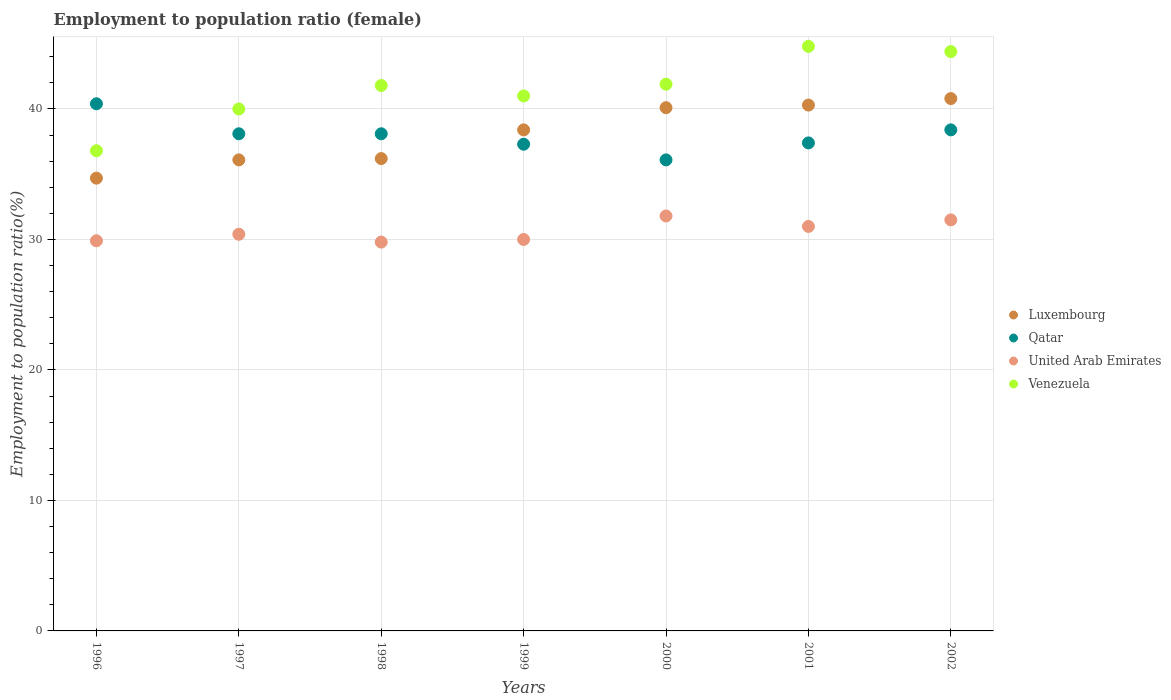Is the number of dotlines equal to the number of legend labels?
Offer a very short reply. Yes. What is the employment to population ratio in Luxembourg in 1999?
Your answer should be compact. 38.4. Across all years, what is the maximum employment to population ratio in Luxembourg?
Your answer should be very brief. 40.8. Across all years, what is the minimum employment to population ratio in United Arab Emirates?
Ensure brevity in your answer.  29.8. In which year was the employment to population ratio in United Arab Emirates maximum?
Offer a terse response. 2000. What is the total employment to population ratio in Venezuela in the graph?
Keep it short and to the point. 290.7. What is the difference between the employment to population ratio in Qatar in 1999 and that in 2002?
Ensure brevity in your answer.  -1.1. What is the difference between the employment to population ratio in Venezuela in 2002 and the employment to population ratio in United Arab Emirates in 1996?
Give a very brief answer. 14.5. What is the average employment to population ratio in United Arab Emirates per year?
Make the answer very short. 30.63. In the year 2001, what is the difference between the employment to population ratio in Luxembourg and employment to population ratio in Qatar?
Keep it short and to the point. 2.9. What is the ratio of the employment to population ratio in Luxembourg in 1997 to that in 1998?
Your response must be concise. 1. Is the employment to population ratio in United Arab Emirates in 1999 less than that in 2001?
Give a very brief answer. Yes. What is the difference between the highest and the second highest employment to population ratio in United Arab Emirates?
Ensure brevity in your answer.  0.3. In how many years, is the employment to population ratio in United Arab Emirates greater than the average employment to population ratio in United Arab Emirates taken over all years?
Your response must be concise. 3. Is the sum of the employment to population ratio in Luxembourg in 1999 and 2001 greater than the maximum employment to population ratio in Venezuela across all years?
Give a very brief answer. Yes. Is it the case that in every year, the sum of the employment to population ratio in Qatar and employment to population ratio in Luxembourg  is greater than the employment to population ratio in Venezuela?
Your answer should be very brief. Yes. How many dotlines are there?
Keep it short and to the point. 4. Are the values on the major ticks of Y-axis written in scientific E-notation?
Ensure brevity in your answer.  No. Does the graph contain any zero values?
Give a very brief answer. No. How many legend labels are there?
Keep it short and to the point. 4. What is the title of the graph?
Ensure brevity in your answer.  Employment to population ratio (female). What is the Employment to population ratio(%) in Luxembourg in 1996?
Offer a very short reply. 34.7. What is the Employment to population ratio(%) in Qatar in 1996?
Your response must be concise. 40.4. What is the Employment to population ratio(%) of United Arab Emirates in 1996?
Offer a very short reply. 29.9. What is the Employment to population ratio(%) in Venezuela in 1996?
Ensure brevity in your answer.  36.8. What is the Employment to population ratio(%) in Luxembourg in 1997?
Your answer should be very brief. 36.1. What is the Employment to population ratio(%) in Qatar in 1997?
Make the answer very short. 38.1. What is the Employment to population ratio(%) in United Arab Emirates in 1997?
Ensure brevity in your answer.  30.4. What is the Employment to population ratio(%) of Luxembourg in 1998?
Ensure brevity in your answer.  36.2. What is the Employment to population ratio(%) of Qatar in 1998?
Your answer should be compact. 38.1. What is the Employment to population ratio(%) of United Arab Emirates in 1998?
Ensure brevity in your answer.  29.8. What is the Employment to population ratio(%) in Venezuela in 1998?
Make the answer very short. 41.8. What is the Employment to population ratio(%) in Luxembourg in 1999?
Your answer should be compact. 38.4. What is the Employment to population ratio(%) in Qatar in 1999?
Give a very brief answer. 37.3. What is the Employment to population ratio(%) in United Arab Emirates in 1999?
Make the answer very short. 30. What is the Employment to population ratio(%) in Venezuela in 1999?
Keep it short and to the point. 41. What is the Employment to population ratio(%) of Luxembourg in 2000?
Give a very brief answer. 40.1. What is the Employment to population ratio(%) of Qatar in 2000?
Make the answer very short. 36.1. What is the Employment to population ratio(%) in United Arab Emirates in 2000?
Provide a short and direct response. 31.8. What is the Employment to population ratio(%) in Venezuela in 2000?
Your answer should be compact. 41.9. What is the Employment to population ratio(%) of Luxembourg in 2001?
Make the answer very short. 40.3. What is the Employment to population ratio(%) in Qatar in 2001?
Give a very brief answer. 37.4. What is the Employment to population ratio(%) of United Arab Emirates in 2001?
Your response must be concise. 31. What is the Employment to population ratio(%) of Venezuela in 2001?
Offer a very short reply. 44.8. What is the Employment to population ratio(%) of Luxembourg in 2002?
Your response must be concise. 40.8. What is the Employment to population ratio(%) in Qatar in 2002?
Offer a terse response. 38.4. What is the Employment to population ratio(%) in United Arab Emirates in 2002?
Give a very brief answer. 31.5. What is the Employment to population ratio(%) of Venezuela in 2002?
Your answer should be very brief. 44.4. Across all years, what is the maximum Employment to population ratio(%) of Luxembourg?
Offer a very short reply. 40.8. Across all years, what is the maximum Employment to population ratio(%) of Qatar?
Provide a short and direct response. 40.4. Across all years, what is the maximum Employment to population ratio(%) in United Arab Emirates?
Provide a short and direct response. 31.8. Across all years, what is the maximum Employment to population ratio(%) in Venezuela?
Provide a succinct answer. 44.8. Across all years, what is the minimum Employment to population ratio(%) in Luxembourg?
Your answer should be compact. 34.7. Across all years, what is the minimum Employment to population ratio(%) of Qatar?
Offer a very short reply. 36.1. Across all years, what is the minimum Employment to population ratio(%) in United Arab Emirates?
Give a very brief answer. 29.8. Across all years, what is the minimum Employment to population ratio(%) in Venezuela?
Make the answer very short. 36.8. What is the total Employment to population ratio(%) in Luxembourg in the graph?
Keep it short and to the point. 266.6. What is the total Employment to population ratio(%) of Qatar in the graph?
Offer a very short reply. 265.8. What is the total Employment to population ratio(%) of United Arab Emirates in the graph?
Provide a succinct answer. 214.4. What is the total Employment to population ratio(%) of Venezuela in the graph?
Offer a very short reply. 290.7. What is the difference between the Employment to population ratio(%) of Qatar in 1996 and that in 1997?
Ensure brevity in your answer.  2.3. What is the difference between the Employment to population ratio(%) in United Arab Emirates in 1996 and that in 1997?
Keep it short and to the point. -0.5. What is the difference between the Employment to population ratio(%) of Venezuela in 1996 and that in 1997?
Your response must be concise. -3.2. What is the difference between the Employment to population ratio(%) of Luxembourg in 1996 and that in 1998?
Ensure brevity in your answer.  -1.5. What is the difference between the Employment to population ratio(%) of Venezuela in 1996 and that in 1998?
Provide a succinct answer. -5. What is the difference between the Employment to population ratio(%) in Luxembourg in 1996 and that in 1999?
Your answer should be compact. -3.7. What is the difference between the Employment to population ratio(%) in Qatar in 1996 and that in 1999?
Offer a terse response. 3.1. What is the difference between the Employment to population ratio(%) of Venezuela in 1996 and that in 2001?
Keep it short and to the point. -8. What is the difference between the Employment to population ratio(%) of Luxembourg in 1997 and that in 1998?
Ensure brevity in your answer.  -0.1. What is the difference between the Employment to population ratio(%) of Qatar in 1997 and that in 1999?
Ensure brevity in your answer.  0.8. What is the difference between the Employment to population ratio(%) in United Arab Emirates in 1997 and that in 1999?
Give a very brief answer. 0.4. What is the difference between the Employment to population ratio(%) of Qatar in 1997 and that in 2000?
Ensure brevity in your answer.  2. What is the difference between the Employment to population ratio(%) in United Arab Emirates in 1997 and that in 2000?
Your response must be concise. -1.4. What is the difference between the Employment to population ratio(%) of Qatar in 1997 and that in 2001?
Ensure brevity in your answer.  0.7. What is the difference between the Employment to population ratio(%) in Venezuela in 1997 and that in 2001?
Offer a very short reply. -4.8. What is the difference between the Employment to population ratio(%) of Qatar in 1997 and that in 2002?
Offer a terse response. -0.3. What is the difference between the Employment to population ratio(%) of Qatar in 1998 and that in 1999?
Ensure brevity in your answer.  0.8. What is the difference between the Employment to population ratio(%) in Luxembourg in 1998 and that in 2000?
Ensure brevity in your answer.  -3.9. What is the difference between the Employment to population ratio(%) of United Arab Emirates in 1998 and that in 2000?
Ensure brevity in your answer.  -2. What is the difference between the Employment to population ratio(%) of Venezuela in 1998 and that in 2000?
Make the answer very short. -0.1. What is the difference between the Employment to population ratio(%) in Luxembourg in 1998 and that in 2001?
Provide a succinct answer. -4.1. What is the difference between the Employment to population ratio(%) in Qatar in 1998 and that in 2001?
Provide a short and direct response. 0.7. What is the difference between the Employment to population ratio(%) in Venezuela in 1998 and that in 2001?
Give a very brief answer. -3. What is the difference between the Employment to population ratio(%) in Luxembourg in 1998 and that in 2002?
Provide a succinct answer. -4.6. What is the difference between the Employment to population ratio(%) of Qatar in 1998 and that in 2002?
Make the answer very short. -0.3. What is the difference between the Employment to population ratio(%) of Qatar in 1999 and that in 2000?
Offer a very short reply. 1.2. What is the difference between the Employment to population ratio(%) in United Arab Emirates in 1999 and that in 2000?
Offer a terse response. -1.8. What is the difference between the Employment to population ratio(%) of Venezuela in 1999 and that in 2000?
Provide a short and direct response. -0.9. What is the difference between the Employment to population ratio(%) of Luxembourg in 1999 and that in 2001?
Offer a terse response. -1.9. What is the difference between the Employment to population ratio(%) of Qatar in 1999 and that in 2001?
Your response must be concise. -0.1. What is the difference between the Employment to population ratio(%) of Venezuela in 1999 and that in 2001?
Your response must be concise. -3.8. What is the difference between the Employment to population ratio(%) in Qatar in 1999 and that in 2002?
Offer a terse response. -1.1. What is the difference between the Employment to population ratio(%) in United Arab Emirates in 1999 and that in 2002?
Provide a short and direct response. -1.5. What is the difference between the Employment to population ratio(%) in Luxembourg in 2000 and that in 2001?
Keep it short and to the point. -0.2. What is the difference between the Employment to population ratio(%) in Qatar in 2000 and that in 2001?
Your response must be concise. -1.3. What is the difference between the Employment to population ratio(%) of United Arab Emirates in 2000 and that in 2001?
Your answer should be compact. 0.8. What is the difference between the Employment to population ratio(%) of Qatar in 2000 and that in 2002?
Offer a very short reply. -2.3. What is the difference between the Employment to population ratio(%) in United Arab Emirates in 2000 and that in 2002?
Your answer should be compact. 0.3. What is the difference between the Employment to population ratio(%) of Venezuela in 2000 and that in 2002?
Your response must be concise. -2.5. What is the difference between the Employment to population ratio(%) of Venezuela in 2001 and that in 2002?
Provide a succinct answer. 0.4. What is the difference between the Employment to population ratio(%) in Luxembourg in 1996 and the Employment to population ratio(%) in Venezuela in 1997?
Provide a succinct answer. -5.3. What is the difference between the Employment to population ratio(%) in Qatar in 1996 and the Employment to population ratio(%) in Venezuela in 1997?
Keep it short and to the point. 0.4. What is the difference between the Employment to population ratio(%) of United Arab Emirates in 1996 and the Employment to population ratio(%) of Venezuela in 1997?
Your answer should be compact. -10.1. What is the difference between the Employment to population ratio(%) of Luxembourg in 1996 and the Employment to population ratio(%) of Qatar in 1998?
Make the answer very short. -3.4. What is the difference between the Employment to population ratio(%) of Luxembourg in 1996 and the Employment to population ratio(%) of Venezuela in 1998?
Your answer should be very brief. -7.1. What is the difference between the Employment to population ratio(%) in Qatar in 1996 and the Employment to population ratio(%) in Venezuela in 1998?
Your answer should be very brief. -1.4. What is the difference between the Employment to population ratio(%) of United Arab Emirates in 1996 and the Employment to population ratio(%) of Venezuela in 1998?
Give a very brief answer. -11.9. What is the difference between the Employment to population ratio(%) in Luxembourg in 1996 and the Employment to population ratio(%) in United Arab Emirates in 1999?
Make the answer very short. 4.7. What is the difference between the Employment to population ratio(%) of Luxembourg in 1996 and the Employment to population ratio(%) of Qatar in 2000?
Give a very brief answer. -1.4. What is the difference between the Employment to population ratio(%) of Luxembourg in 1996 and the Employment to population ratio(%) of United Arab Emirates in 2000?
Your answer should be very brief. 2.9. What is the difference between the Employment to population ratio(%) of Luxembourg in 1996 and the Employment to population ratio(%) of Venezuela in 2000?
Your response must be concise. -7.2. What is the difference between the Employment to population ratio(%) in Qatar in 1996 and the Employment to population ratio(%) in United Arab Emirates in 2000?
Offer a terse response. 8.6. What is the difference between the Employment to population ratio(%) of Qatar in 1996 and the Employment to population ratio(%) of Venezuela in 2000?
Provide a succinct answer. -1.5. What is the difference between the Employment to population ratio(%) in United Arab Emirates in 1996 and the Employment to population ratio(%) in Venezuela in 2000?
Ensure brevity in your answer.  -12. What is the difference between the Employment to population ratio(%) in Luxembourg in 1996 and the Employment to population ratio(%) in Qatar in 2001?
Your response must be concise. -2.7. What is the difference between the Employment to population ratio(%) of Luxembourg in 1996 and the Employment to population ratio(%) of United Arab Emirates in 2001?
Offer a terse response. 3.7. What is the difference between the Employment to population ratio(%) of United Arab Emirates in 1996 and the Employment to population ratio(%) of Venezuela in 2001?
Your answer should be very brief. -14.9. What is the difference between the Employment to population ratio(%) of Luxembourg in 1996 and the Employment to population ratio(%) of United Arab Emirates in 2002?
Provide a succinct answer. 3.2. What is the difference between the Employment to population ratio(%) in Luxembourg in 1996 and the Employment to population ratio(%) in Venezuela in 2002?
Your answer should be very brief. -9.7. What is the difference between the Employment to population ratio(%) in Qatar in 1996 and the Employment to population ratio(%) in Venezuela in 2002?
Ensure brevity in your answer.  -4. What is the difference between the Employment to population ratio(%) of Luxembourg in 1997 and the Employment to population ratio(%) of Qatar in 1998?
Provide a succinct answer. -2. What is the difference between the Employment to population ratio(%) in Luxembourg in 1997 and the Employment to population ratio(%) in United Arab Emirates in 1998?
Keep it short and to the point. 6.3. What is the difference between the Employment to population ratio(%) of Qatar in 1997 and the Employment to population ratio(%) of Venezuela in 1998?
Give a very brief answer. -3.7. What is the difference between the Employment to population ratio(%) of United Arab Emirates in 1997 and the Employment to population ratio(%) of Venezuela in 1998?
Your answer should be compact. -11.4. What is the difference between the Employment to population ratio(%) in Luxembourg in 1997 and the Employment to population ratio(%) in Venezuela in 1999?
Provide a short and direct response. -4.9. What is the difference between the Employment to population ratio(%) of Qatar in 1997 and the Employment to population ratio(%) of Venezuela in 1999?
Your answer should be very brief. -2.9. What is the difference between the Employment to population ratio(%) in Luxembourg in 1997 and the Employment to population ratio(%) in Qatar in 2000?
Offer a terse response. 0. What is the difference between the Employment to population ratio(%) in Luxembourg in 1997 and the Employment to population ratio(%) in Qatar in 2001?
Provide a short and direct response. -1.3. What is the difference between the Employment to population ratio(%) in Luxembourg in 1997 and the Employment to population ratio(%) in United Arab Emirates in 2001?
Keep it short and to the point. 5.1. What is the difference between the Employment to population ratio(%) of Qatar in 1997 and the Employment to population ratio(%) of United Arab Emirates in 2001?
Make the answer very short. 7.1. What is the difference between the Employment to population ratio(%) in United Arab Emirates in 1997 and the Employment to population ratio(%) in Venezuela in 2001?
Offer a terse response. -14.4. What is the difference between the Employment to population ratio(%) in Luxembourg in 1997 and the Employment to population ratio(%) in United Arab Emirates in 2002?
Provide a short and direct response. 4.6. What is the difference between the Employment to population ratio(%) in Luxembourg in 1997 and the Employment to population ratio(%) in Venezuela in 2002?
Provide a succinct answer. -8.3. What is the difference between the Employment to population ratio(%) of Qatar in 1997 and the Employment to population ratio(%) of United Arab Emirates in 2002?
Provide a succinct answer. 6.6. What is the difference between the Employment to population ratio(%) of United Arab Emirates in 1997 and the Employment to population ratio(%) of Venezuela in 2002?
Keep it short and to the point. -14. What is the difference between the Employment to population ratio(%) of Luxembourg in 1998 and the Employment to population ratio(%) of Qatar in 1999?
Your response must be concise. -1.1. What is the difference between the Employment to population ratio(%) of Luxembourg in 1998 and the Employment to population ratio(%) of United Arab Emirates in 1999?
Your response must be concise. 6.2. What is the difference between the Employment to population ratio(%) in Qatar in 1998 and the Employment to population ratio(%) in United Arab Emirates in 1999?
Offer a very short reply. 8.1. What is the difference between the Employment to population ratio(%) in Luxembourg in 1998 and the Employment to population ratio(%) in Qatar in 2000?
Make the answer very short. 0.1. What is the difference between the Employment to population ratio(%) in Luxembourg in 1998 and the Employment to population ratio(%) in Qatar in 2001?
Provide a short and direct response. -1.2. What is the difference between the Employment to population ratio(%) in Qatar in 1998 and the Employment to population ratio(%) in United Arab Emirates in 2001?
Your answer should be compact. 7.1. What is the difference between the Employment to population ratio(%) in Qatar in 1998 and the Employment to population ratio(%) in Venezuela in 2001?
Your answer should be compact. -6.7. What is the difference between the Employment to population ratio(%) in Luxembourg in 1998 and the Employment to population ratio(%) in Qatar in 2002?
Offer a very short reply. -2.2. What is the difference between the Employment to population ratio(%) in Luxembourg in 1998 and the Employment to population ratio(%) in Venezuela in 2002?
Keep it short and to the point. -8.2. What is the difference between the Employment to population ratio(%) of Qatar in 1998 and the Employment to population ratio(%) of United Arab Emirates in 2002?
Ensure brevity in your answer.  6.6. What is the difference between the Employment to population ratio(%) of Qatar in 1998 and the Employment to population ratio(%) of Venezuela in 2002?
Your response must be concise. -6.3. What is the difference between the Employment to population ratio(%) in United Arab Emirates in 1998 and the Employment to population ratio(%) in Venezuela in 2002?
Your response must be concise. -14.6. What is the difference between the Employment to population ratio(%) in Luxembourg in 1999 and the Employment to population ratio(%) in United Arab Emirates in 2000?
Your response must be concise. 6.6. What is the difference between the Employment to population ratio(%) in Qatar in 1999 and the Employment to population ratio(%) in United Arab Emirates in 2000?
Give a very brief answer. 5.5. What is the difference between the Employment to population ratio(%) of Qatar in 1999 and the Employment to population ratio(%) of Venezuela in 2000?
Give a very brief answer. -4.6. What is the difference between the Employment to population ratio(%) of United Arab Emirates in 1999 and the Employment to population ratio(%) of Venezuela in 2000?
Your answer should be very brief. -11.9. What is the difference between the Employment to population ratio(%) in Luxembourg in 1999 and the Employment to population ratio(%) in Qatar in 2001?
Provide a short and direct response. 1. What is the difference between the Employment to population ratio(%) of Luxembourg in 1999 and the Employment to population ratio(%) of United Arab Emirates in 2001?
Keep it short and to the point. 7.4. What is the difference between the Employment to population ratio(%) of United Arab Emirates in 1999 and the Employment to population ratio(%) of Venezuela in 2001?
Provide a succinct answer. -14.8. What is the difference between the Employment to population ratio(%) in Luxembourg in 1999 and the Employment to population ratio(%) in Qatar in 2002?
Ensure brevity in your answer.  0. What is the difference between the Employment to population ratio(%) in Luxembourg in 1999 and the Employment to population ratio(%) in Venezuela in 2002?
Provide a succinct answer. -6. What is the difference between the Employment to population ratio(%) of United Arab Emirates in 1999 and the Employment to population ratio(%) of Venezuela in 2002?
Provide a succinct answer. -14.4. What is the difference between the Employment to population ratio(%) of Luxembourg in 2000 and the Employment to population ratio(%) of Qatar in 2001?
Provide a short and direct response. 2.7. What is the difference between the Employment to population ratio(%) in Luxembourg in 2000 and the Employment to population ratio(%) in Venezuela in 2001?
Provide a succinct answer. -4.7. What is the difference between the Employment to population ratio(%) in Qatar in 2000 and the Employment to population ratio(%) in United Arab Emirates in 2001?
Ensure brevity in your answer.  5.1. What is the difference between the Employment to population ratio(%) of United Arab Emirates in 2000 and the Employment to population ratio(%) of Venezuela in 2001?
Give a very brief answer. -13. What is the difference between the Employment to population ratio(%) in Qatar in 2000 and the Employment to population ratio(%) in United Arab Emirates in 2002?
Offer a terse response. 4.6. What is the difference between the Employment to population ratio(%) of Qatar in 2000 and the Employment to population ratio(%) of Venezuela in 2002?
Provide a short and direct response. -8.3. What is the difference between the Employment to population ratio(%) in Luxembourg in 2001 and the Employment to population ratio(%) in Qatar in 2002?
Your answer should be compact. 1.9. What is the difference between the Employment to population ratio(%) in Luxembourg in 2001 and the Employment to population ratio(%) in United Arab Emirates in 2002?
Give a very brief answer. 8.8. What is the difference between the Employment to population ratio(%) in United Arab Emirates in 2001 and the Employment to population ratio(%) in Venezuela in 2002?
Keep it short and to the point. -13.4. What is the average Employment to population ratio(%) in Luxembourg per year?
Provide a short and direct response. 38.09. What is the average Employment to population ratio(%) of Qatar per year?
Provide a short and direct response. 37.97. What is the average Employment to population ratio(%) in United Arab Emirates per year?
Offer a very short reply. 30.63. What is the average Employment to population ratio(%) of Venezuela per year?
Provide a short and direct response. 41.53. In the year 1996, what is the difference between the Employment to population ratio(%) of Qatar and Employment to population ratio(%) of United Arab Emirates?
Keep it short and to the point. 10.5. In the year 1996, what is the difference between the Employment to population ratio(%) in Qatar and Employment to population ratio(%) in Venezuela?
Keep it short and to the point. 3.6. In the year 1996, what is the difference between the Employment to population ratio(%) of United Arab Emirates and Employment to population ratio(%) of Venezuela?
Your answer should be compact. -6.9. In the year 1997, what is the difference between the Employment to population ratio(%) of Luxembourg and Employment to population ratio(%) of Venezuela?
Offer a terse response. -3.9. In the year 1998, what is the difference between the Employment to population ratio(%) in Luxembourg and Employment to population ratio(%) in United Arab Emirates?
Offer a terse response. 6.4. In the year 1998, what is the difference between the Employment to population ratio(%) in Luxembourg and Employment to population ratio(%) in Venezuela?
Your response must be concise. -5.6. In the year 1998, what is the difference between the Employment to population ratio(%) in Qatar and Employment to population ratio(%) in United Arab Emirates?
Offer a very short reply. 8.3. In the year 1999, what is the difference between the Employment to population ratio(%) in Luxembourg and Employment to population ratio(%) in Qatar?
Keep it short and to the point. 1.1. In the year 1999, what is the difference between the Employment to population ratio(%) of Luxembourg and Employment to population ratio(%) of United Arab Emirates?
Your response must be concise. 8.4. In the year 1999, what is the difference between the Employment to population ratio(%) in Luxembourg and Employment to population ratio(%) in Venezuela?
Your answer should be compact. -2.6. In the year 1999, what is the difference between the Employment to population ratio(%) in Qatar and Employment to population ratio(%) in Venezuela?
Your answer should be very brief. -3.7. In the year 2000, what is the difference between the Employment to population ratio(%) of Luxembourg and Employment to population ratio(%) of Qatar?
Your response must be concise. 4. In the year 2000, what is the difference between the Employment to population ratio(%) of Luxembourg and Employment to population ratio(%) of Venezuela?
Your answer should be compact. -1.8. In the year 2000, what is the difference between the Employment to population ratio(%) in Qatar and Employment to population ratio(%) in United Arab Emirates?
Give a very brief answer. 4.3. In the year 2001, what is the difference between the Employment to population ratio(%) in Luxembourg and Employment to population ratio(%) in Qatar?
Keep it short and to the point. 2.9. In the year 2002, what is the difference between the Employment to population ratio(%) in Luxembourg and Employment to population ratio(%) in United Arab Emirates?
Your answer should be compact. 9.3. In the year 2002, what is the difference between the Employment to population ratio(%) of Qatar and Employment to population ratio(%) of Venezuela?
Make the answer very short. -6. What is the ratio of the Employment to population ratio(%) of Luxembourg in 1996 to that in 1997?
Give a very brief answer. 0.96. What is the ratio of the Employment to population ratio(%) in Qatar in 1996 to that in 1997?
Your answer should be compact. 1.06. What is the ratio of the Employment to population ratio(%) in United Arab Emirates in 1996 to that in 1997?
Ensure brevity in your answer.  0.98. What is the ratio of the Employment to population ratio(%) of Luxembourg in 1996 to that in 1998?
Your answer should be compact. 0.96. What is the ratio of the Employment to population ratio(%) of Qatar in 1996 to that in 1998?
Ensure brevity in your answer.  1.06. What is the ratio of the Employment to population ratio(%) of Venezuela in 1996 to that in 1998?
Your response must be concise. 0.88. What is the ratio of the Employment to population ratio(%) of Luxembourg in 1996 to that in 1999?
Your answer should be compact. 0.9. What is the ratio of the Employment to population ratio(%) in Qatar in 1996 to that in 1999?
Your response must be concise. 1.08. What is the ratio of the Employment to population ratio(%) in Venezuela in 1996 to that in 1999?
Make the answer very short. 0.9. What is the ratio of the Employment to population ratio(%) in Luxembourg in 1996 to that in 2000?
Your response must be concise. 0.87. What is the ratio of the Employment to population ratio(%) in Qatar in 1996 to that in 2000?
Your answer should be compact. 1.12. What is the ratio of the Employment to population ratio(%) of United Arab Emirates in 1996 to that in 2000?
Provide a short and direct response. 0.94. What is the ratio of the Employment to population ratio(%) of Venezuela in 1996 to that in 2000?
Give a very brief answer. 0.88. What is the ratio of the Employment to population ratio(%) in Luxembourg in 1996 to that in 2001?
Provide a succinct answer. 0.86. What is the ratio of the Employment to population ratio(%) of Qatar in 1996 to that in 2001?
Offer a very short reply. 1.08. What is the ratio of the Employment to population ratio(%) in United Arab Emirates in 1996 to that in 2001?
Ensure brevity in your answer.  0.96. What is the ratio of the Employment to population ratio(%) of Venezuela in 1996 to that in 2001?
Your response must be concise. 0.82. What is the ratio of the Employment to population ratio(%) of Luxembourg in 1996 to that in 2002?
Provide a short and direct response. 0.85. What is the ratio of the Employment to population ratio(%) in Qatar in 1996 to that in 2002?
Your answer should be compact. 1.05. What is the ratio of the Employment to population ratio(%) of United Arab Emirates in 1996 to that in 2002?
Ensure brevity in your answer.  0.95. What is the ratio of the Employment to population ratio(%) of Venezuela in 1996 to that in 2002?
Your response must be concise. 0.83. What is the ratio of the Employment to population ratio(%) of Luxembourg in 1997 to that in 1998?
Make the answer very short. 1. What is the ratio of the Employment to population ratio(%) of United Arab Emirates in 1997 to that in 1998?
Your answer should be compact. 1.02. What is the ratio of the Employment to population ratio(%) of Venezuela in 1997 to that in 1998?
Your response must be concise. 0.96. What is the ratio of the Employment to population ratio(%) in Luxembourg in 1997 to that in 1999?
Your answer should be very brief. 0.94. What is the ratio of the Employment to population ratio(%) of Qatar in 1997 to that in 1999?
Your response must be concise. 1.02. What is the ratio of the Employment to population ratio(%) of United Arab Emirates in 1997 to that in 1999?
Offer a very short reply. 1.01. What is the ratio of the Employment to population ratio(%) of Venezuela in 1997 to that in 1999?
Keep it short and to the point. 0.98. What is the ratio of the Employment to population ratio(%) in Luxembourg in 1997 to that in 2000?
Offer a very short reply. 0.9. What is the ratio of the Employment to population ratio(%) of Qatar in 1997 to that in 2000?
Provide a succinct answer. 1.06. What is the ratio of the Employment to population ratio(%) in United Arab Emirates in 1997 to that in 2000?
Offer a very short reply. 0.96. What is the ratio of the Employment to population ratio(%) in Venezuela in 1997 to that in 2000?
Provide a succinct answer. 0.95. What is the ratio of the Employment to population ratio(%) of Luxembourg in 1997 to that in 2001?
Make the answer very short. 0.9. What is the ratio of the Employment to population ratio(%) in Qatar in 1997 to that in 2001?
Make the answer very short. 1.02. What is the ratio of the Employment to population ratio(%) in United Arab Emirates in 1997 to that in 2001?
Provide a short and direct response. 0.98. What is the ratio of the Employment to population ratio(%) in Venezuela in 1997 to that in 2001?
Give a very brief answer. 0.89. What is the ratio of the Employment to population ratio(%) in Luxembourg in 1997 to that in 2002?
Provide a succinct answer. 0.88. What is the ratio of the Employment to population ratio(%) of Qatar in 1997 to that in 2002?
Your answer should be compact. 0.99. What is the ratio of the Employment to population ratio(%) of United Arab Emirates in 1997 to that in 2002?
Keep it short and to the point. 0.97. What is the ratio of the Employment to population ratio(%) of Venezuela in 1997 to that in 2002?
Offer a very short reply. 0.9. What is the ratio of the Employment to population ratio(%) of Luxembourg in 1998 to that in 1999?
Provide a short and direct response. 0.94. What is the ratio of the Employment to population ratio(%) of Qatar in 1998 to that in 1999?
Your response must be concise. 1.02. What is the ratio of the Employment to population ratio(%) in Venezuela in 1998 to that in 1999?
Your response must be concise. 1.02. What is the ratio of the Employment to population ratio(%) of Luxembourg in 1998 to that in 2000?
Ensure brevity in your answer.  0.9. What is the ratio of the Employment to population ratio(%) in Qatar in 1998 to that in 2000?
Offer a terse response. 1.06. What is the ratio of the Employment to population ratio(%) of United Arab Emirates in 1998 to that in 2000?
Make the answer very short. 0.94. What is the ratio of the Employment to population ratio(%) in Venezuela in 1998 to that in 2000?
Give a very brief answer. 1. What is the ratio of the Employment to population ratio(%) of Luxembourg in 1998 to that in 2001?
Keep it short and to the point. 0.9. What is the ratio of the Employment to population ratio(%) in Qatar in 1998 to that in 2001?
Offer a very short reply. 1.02. What is the ratio of the Employment to population ratio(%) of United Arab Emirates in 1998 to that in 2001?
Your answer should be compact. 0.96. What is the ratio of the Employment to population ratio(%) in Venezuela in 1998 to that in 2001?
Your response must be concise. 0.93. What is the ratio of the Employment to population ratio(%) in Luxembourg in 1998 to that in 2002?
Ensure brevity in your answer.  0.89. What is the ratio of the Employment to population ratio(%) of United Arab Emirates in 1998 to that in 2002?
Make the answer very short. 0.95. What is the ratio of the Employment to population ratio(%) of Venezuela in 1998 to that in 2002?
Your response must be concise. 0.94. What is the ratio of the Employment to population ratio(%) of Luxembourg in 1999 to that in 2000?
Provide a succinct answer. 0.96. What is the ratio of the Employment to population ratio(%) in Qatar in 1999 to that in 2000?
Your answer should be compact. 1.03. What is the ratio of the Employment to population ratio(%) of United Arab Emirates in 1999 to that in 2000?
Make the answer very short. 0.94. What is the ratio of the Employment to population ratio(%) in Venezuela in 1999 to that in 2000?
Provide a succinct answer. 0.98. What is the ratio of the Employment to population ratio(%) in Luxembourg in 1999 to that in 2001?
Ensure brevity in your answer.  0.95. What is the ratio of the Employment to population ratio(%) in Qatar in 1999 to that in 2001?
Offer a very short reply. 1. What is the ratio of the Employment to population ratio(%) in Venezuela in 1999 to that in 2001?
Give a very brief answer. 0.92. What is the ratio of the Employment to population ratio(%) in Qatar in 1999 to that in 2002?
Your answer should be very brief. 0.97. What is the ratio of the Employment to population ratio(%) of Venezuela in 1999 to that in 2002?
Your response must be concise. 0.92. What is the ratio of the Employment to population ratio(%) in Luxembourg in 2000 to that in 2001?
Your answer should be very brief. 0.99. What is the ratio of the Employment to population ratio(%) of Qatar in 2000 to that in 2001?
Your answer should be compact. 0.97. What is the ratio of the Employment to population ratio(%) of United Arab Emirates in 2000 to that in 2001?
Your answer should be compact. 1.03. What is the ratio of the Employment to population ratio(%) in Venezuela in 2000 to that in 2001?
Provide a short and direct response. 0.94. What is the ratio of the Employment to population ratio(%) in Luxembourg in 2000 to that in 2002?
Provide a short and direct response. 0.98. What is the ratio of the Employment to population ratio(%) in Qatar in 2000 to that in 2002?
Your answer should be compact. 0.94. What is the ratio of the Employment to population ratio(%) in United Arab Emirates in 2000 to that in 2002?
Your answer should be very brief. 1.01. What is the ratio of the Employment to population ratio(%) in Venezuela in 2000 to that in 2002?
Your response must be concise. 0.94. What is the ratio of the Employment to population ratio(%) in Luxembourg in 2001 to that in 2002?
Ensure brevity in your answer.  0.99. What is the ratio of the Employment to population ratio(%) in United Arab Emirates in 2001 to that in 2002?
Provide a succinct answer. 0.98. What is the difference between the highest and the second highest Employment to population ratio(%) of Luxembourg?
Offer a terse response. 0.5. What is the difference between the highest and the second highest Employment to population ratio(%) of Venezuela?
Keep it short and to the point. 0.4. 